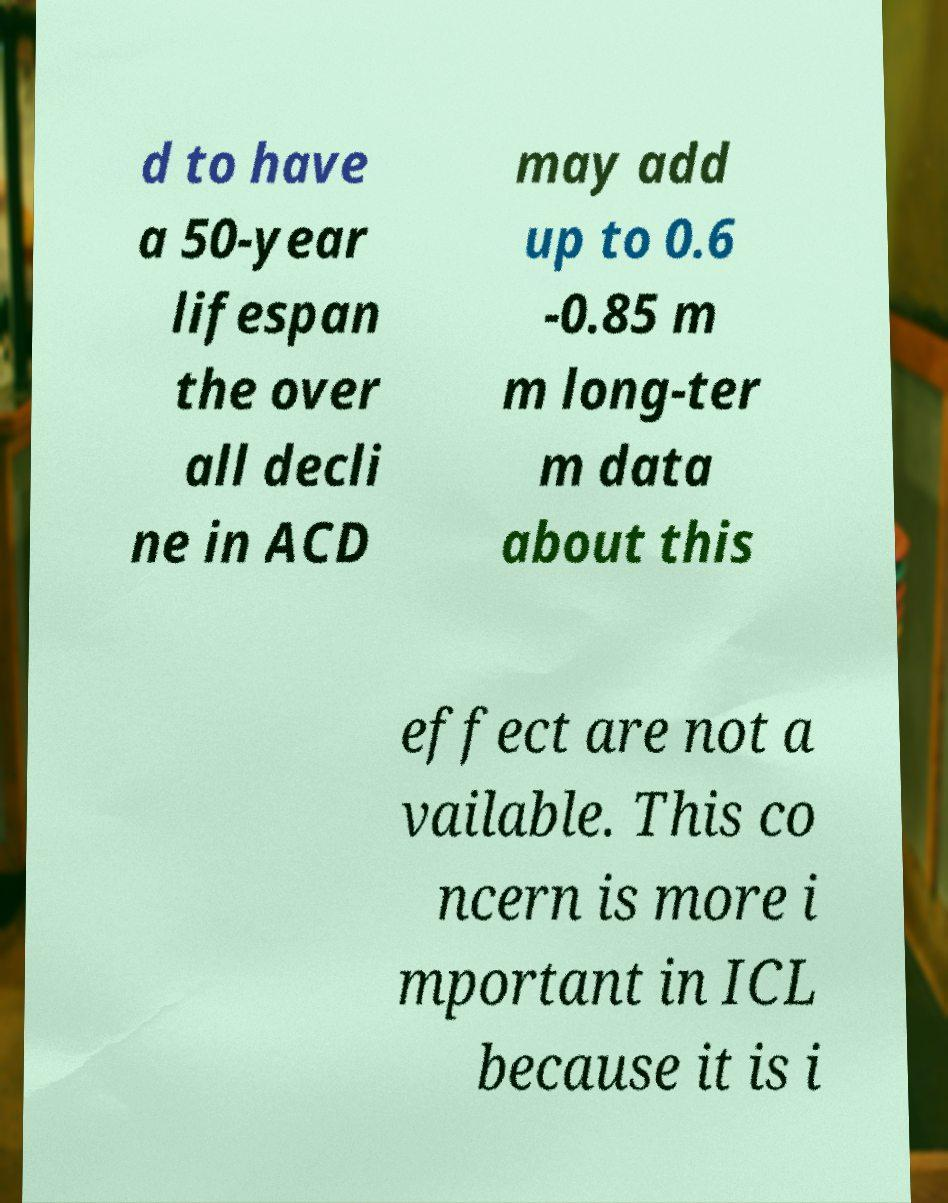Can you accurately transcribe the text from the provided image for me? d to have a 50-year lifespan the over all decli ne in ACD may add up to 0.6 -0.85 m m long-ter m data about this effect are not a vailable. This co ncern is more i mportant in ICL because it is i 